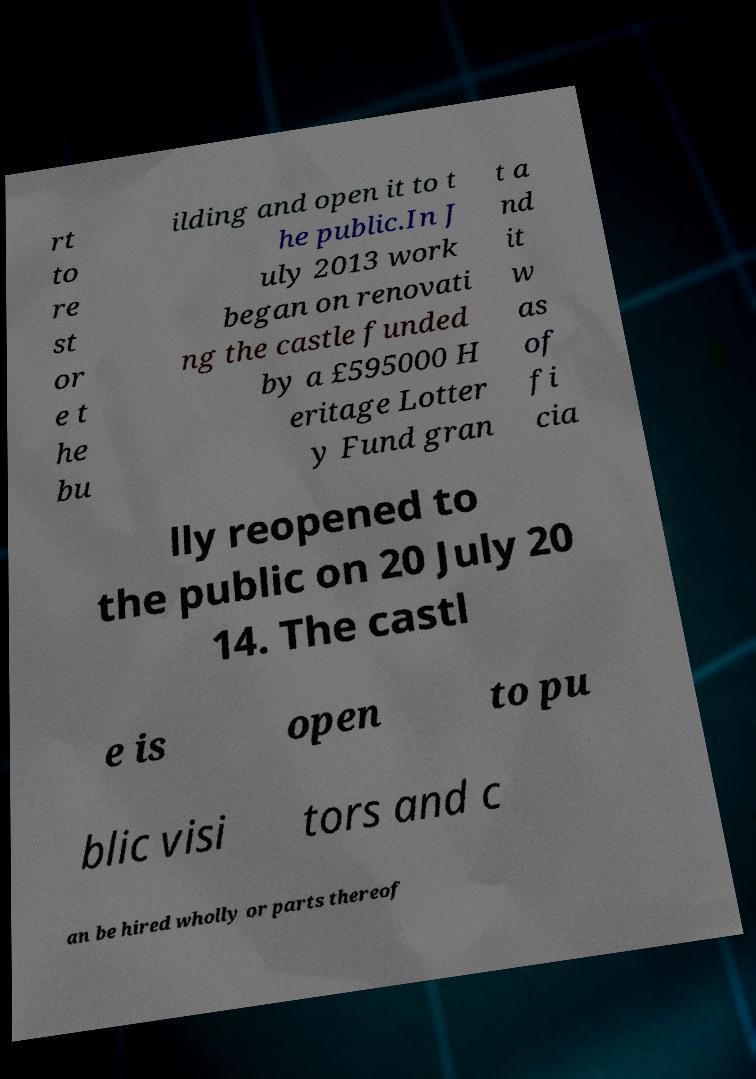Please identify and transcribe the text found in this image. rt to re st or e t he bu ilding and open it to t he public.In J uly 2013 work began on renovati ng the castle funded by a £595000 H eritage Lotter y Fund gran t a nd it w as of fi cia lly reopened to the public on 20 July 20 14. The castl e is open to pu blic visi tors and c an be hired wholly or parts thereof 